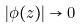<formula> <loc_0><loc_0><loc_500><loc_500>| \phi ( z ) | \rightarrow 0</formula> 